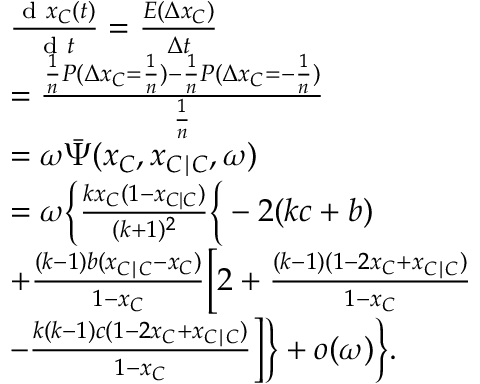Convert formula to latex. <formula><loc_0><loc_0><loc_500><loc_500>\begin{array} { r l } & { \frac { d x _ { C } ( t ) } { d t } = \frac { E ( \Delta x _ { C } ) } { \Delta t } } \\ & { = \frac { \frac { 1 } { n } P ( \Delta x _ { C } = \frac { 1 } { n } ) - \frac { 1 } { n } P ( \Delta x _ { C } = - \frac { 1 } { n } ) } { \frac { 1 } { n } } } \\ & { = \omega \bar { \Psi } ( x _ { C } , x _ { C | C } , \omega ) } \\ & { = \omega \left \{ \frac { k x _ { C } ( 1 - x _ { C | C } ) } { ( k + 1 ) ^ { 2 } } \left \{ - 2 ( k c + b ) } \\ & { + \frac { ( k - 1 ) b ( x _ { C | C } - x _ { C } ) } { 1 - x _ { C } } \left [ 2 + \frac { ( k - 1 ) ( 1 - 2 x _ { C } + x _ { C | C } ) } { 1 - x _ { C } } } \\ & { - \frac { k ( k - 1 ) c ( 1 - 2 x _ { C } + x _ { C | C } ) } { 1 - x _ { C } } \right ] \right \} + o ( \omega ) \right \} . } \end{array}</formula> 